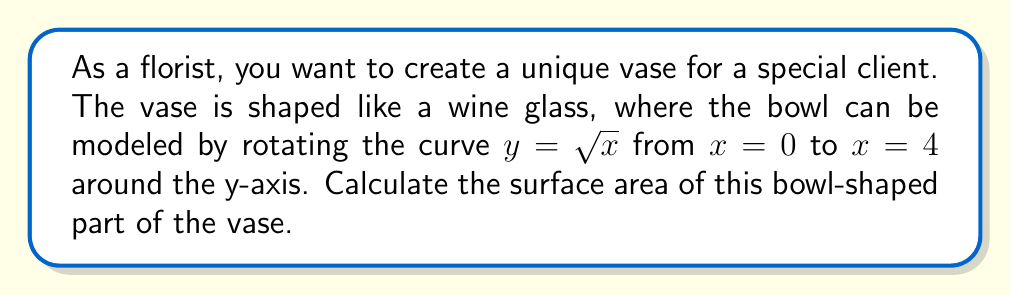Could you help me with this problem? To find the surface area of a solid of revolution, we use the formula:

$$ S = 2\pi \int_{a}^{b} f(x) \sqrt{1 + [f'(x)]^2} dx $$

Where $f(x)$ is the function being rotated and $[a,b]$ is the interval.

1) Our function is $f(x) = \sqrt{x}$, and we're rotating from $x = 0$ to $x = 4$.

2) First, let's find $f'(x)$:
   $$ f'(x) = \frac{1}{2\sqrt{x}} $$

3) Now, let's substitute these into our formula:
   $$ S = 2\pi \int_{0}^{4} \sqrt{x} \sqrt{1 + (\frac{1}{2\sqrt{x}})^2} dx $$

4) Simplify under the square root:
   $$ S = 2\pi \int_{0}^{4} \sqrt{x} \sqrt{1 + \frac{1}{4x}} dx $$
   $$ S = 2\pi \int_{0}^{4} \sqrt{x} \sqrt{\frac{4x+1}{4x}} dx $$

5) This integral is quite complex. We can solve it using the substitution $u = \sqrt{x}$, which gives $du = \frac{1}{2\sqrt{x}}dx$ or $dx = 2udu$. When $x = 0$, $u = 0$, and when $x = 4$, $u = 2$. This transforms our integral to:

   $$ S = 2\pi \int_{0}^{2} u \sqrt{\frac{4u^2+1}{4u^2}} (2u)du $$
   $$ S = 4\pi \int_{0}^{2} u^2 \sqrt{\frac{4u^2+1}{4u^2}} du $$
   $$ S = 4\pi \int_{0}^{2} u \sqrt{4u^2+1} du $$

6) This integral can be solved using hyperbolic substitution, but the process is quite involved. The result is:

   $$ S = \pi \left[ \frac{1}{3}(4u^2+1)^{3/2} - u \right]_{0}^{2} $$

7) Evaluating at the limits:
   $$ S = \pi \left[ \frac{1}{3}(16+1)^{3/2} - 2 - (\frac{1}{3}(0+1)^{3/2} - 0) \right] $$
   $$ S = \pi \left[ \frac{1}{3}(17)^{3/2} - 2 - \frac{1}{3} \right] $$
   $$ S = \pi \left[ \frac{17\sqrt{17}}{3} - \frac{7}{3} \right] $$
Answer: $\pi (\frac{17\sqrt{17}}{3} - \frac{7}{3})$ square units 